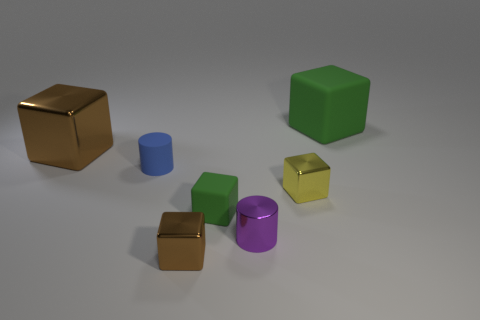What number of small purple cylinders are made of the same material as the yellow cube?
Offer a terse response. 1. What shape is the small rubber thing that is the same color as the large rubber block?
Your answer should be very brief. Cube. The object that is behind the blue rubber thing and to the left of the yellow metal block is made of what material?
Offer a very short reply. Metal. The brown shiny thing in front of the tiny yellow metallic thing has what shape?
Make the answer very short. Cube. There is a brown metal object that is in front of the cube that is on the left side of the tiny brown cube; what is its shape?
Give a very brief answer. Cube. Is there a tiny metallic thing that has the same shape as the tiny blue rubber object?
Give a very brief answer. Yes. What shape is the purple thing that is the same size as the blue matte object?
Provide a short and direct response. Cylinder. Are there any big objects on the right side of the large block that is right of the tiny metallic cube that is on the left side of the yellow object?
Make the answer very short. No. Are there any green rubber things that have the same size as the purple metallic object?
Provide a short and direct response. Yes. There is a shiny thing that is on the left side of the small brown thing; how big is it?
Your answer should be very brief. Large. 